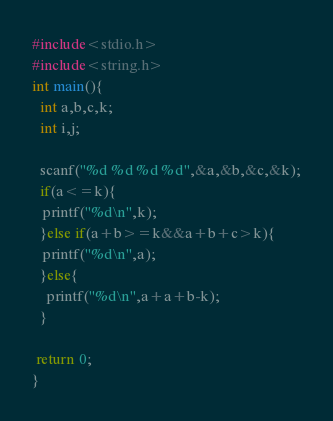<code> <loc_0><loc_0><loc_500><loc_500><_C_>#include<stdio.h>
#include<string.h>
int main(){
  int a,b,c,k;
  int i,j;
  
  scanf("%d %d %d %d",&a,&b,&c,&k);
  if(a<=k){
   printf("%d\n",k);
  }else if(a+b>=k&&a+b+c>k){
   printf("%d\n",a); 
  }else{
    printf("%d\n",a+a+b-k);
  }
  
 return 0; 
}

</code> 